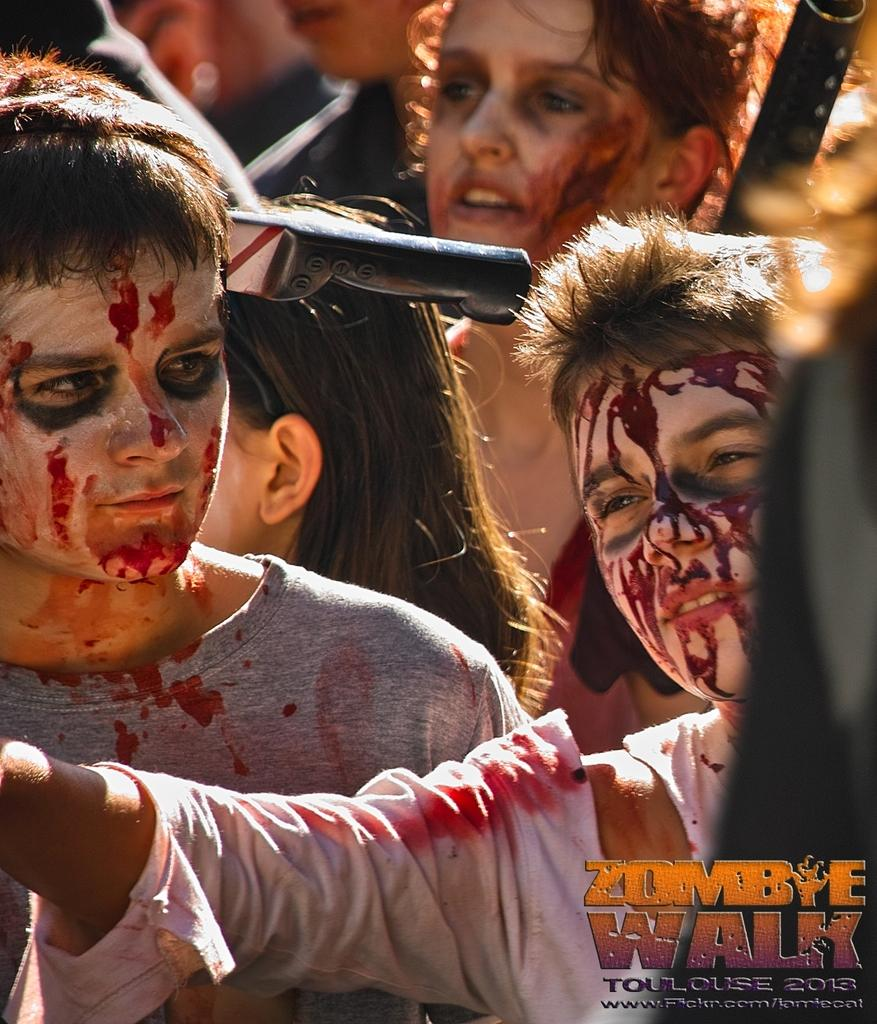How many people are in the image? There is a group of people in the image. What are the people wearing in the image? The people are wearing Halloween costumes. What weapons can be seen in the image? There is a knife and a gun visible in the image. What is present in the bottom right corner of the image? There is text in the bottom right corner of the image. What type of growth can be seen on the doll in the image? There is no doll present in the image, so no growth can be observed. 